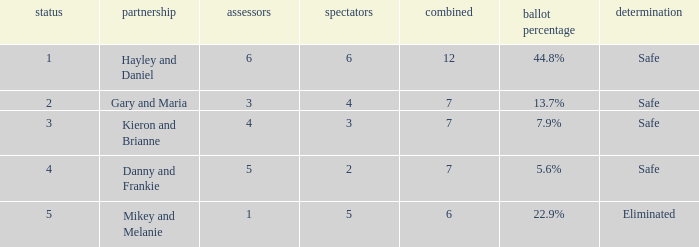What was the maximum rank for the vote percentage of 5.6% 4.0. Would you mind parsing the complete table? {'header': ['status', 'partnership', 'assessors', 'spectators', 'combined', 'ballot percentage', 'determination'], 'rows': [['1', 'Hayley and Daniel', '6', '6', '12', '44.8%', 'Safe'], ['2', 'Gary and Maria', '3', '4', '7', '13.7%', 'Safe'], ['3', 'Kieron and Brianne', '4', '3', '7', '7.9%', 'Safe'], ['4', 'Danny and Frankie', '5', '2', '7', '5.6%', 'Safe'], ['5', 'Mikey and Melanie', '1', '5', '6', '22.9%', 'Eliminated']]} 